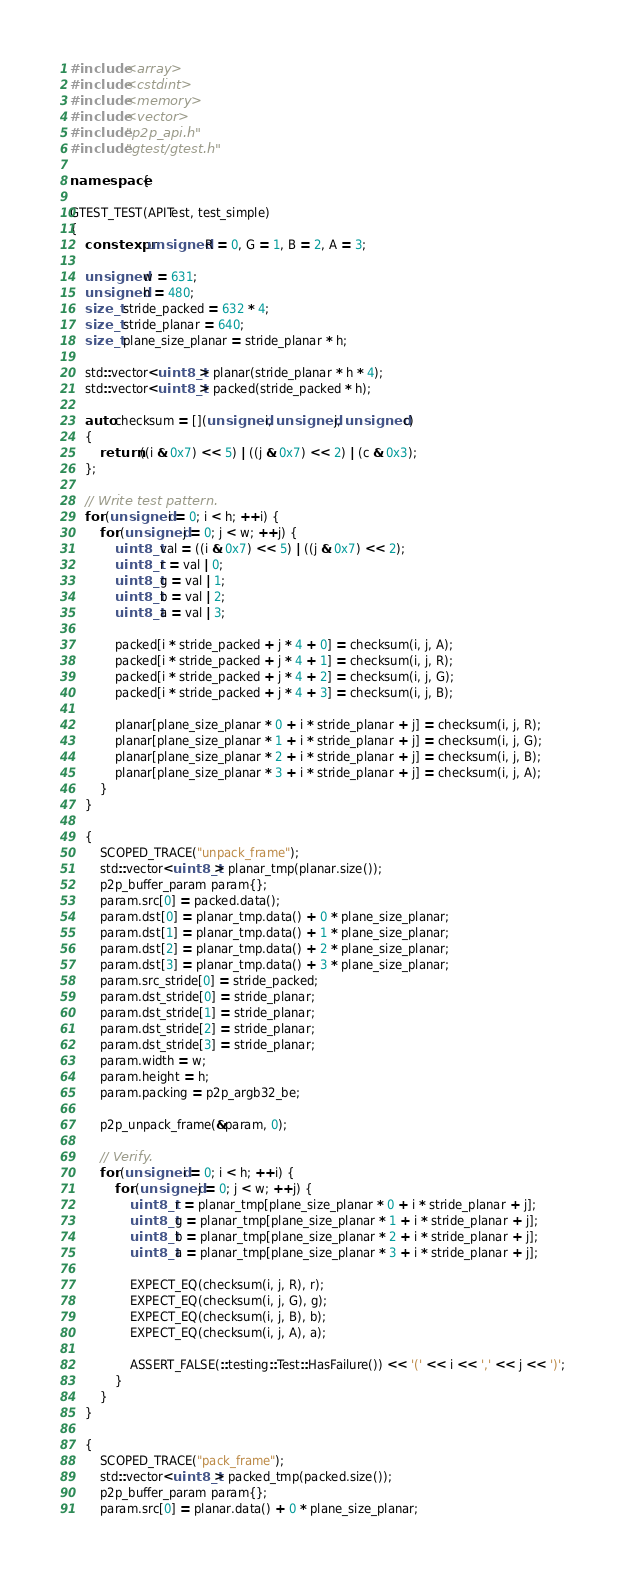Convert code to text. <code><loc_0><loc_0><loc_500><loc_500><_C++_>#include <array>
#include <cstdint>
#include <memory>
#include <vector>
#include "p2p_api.h"
#include "gtest/gtest.h"

namespace {

GTEST_TEST(APITest, test_simple)
{
	constexpr unsigned R = 0, G = 1, B = 2, A = 3;

	unsigned w = 631;
	unsigned h = 480;
	size_t stride_packed = 632 * 4;
	size_t stride_planar = 640;
	size_t plane_size_planar = stride_planar * h;

	std::vector<uint8_t> planar(stride_planar * h * 4);
	std::vector<uint8_t> packed(stride_packed * h);

	auto checksum = [](unsigned i, unsigned j, unsigned c)
	{
		return ((i & 0x7) << 5) | ((j & 0x7) << 2) | (c & 0x3);
	};

	// Write test pattern.
	for (unsigned i = 0; i < h; ++i) {
		for (unsigned j = 0; j < w; ++j) {
			uint8_t val = ((i & 0x7) << 5) | ((j & 0x7) << 2);
			uint8_t r = val | 0;
			uint8_t g = val | 1;
			uint8_t b = val | 2;
			uint8_t a = val | 3;

			packed[i * stride_packed + j * 4 + 0] = checksum(i, j, A);
			packed[i * stride_packed + j * 4 + 1] = checksum(i, j, R);
			packed[i * stride_packed + j * 4 + 2] = checksum(i, j, G);
			packed[i * stride_packed + j * 4 + 3] = checksum(i, j, B);

			planar[plane_size_planar * 0 + i * stride_planar + j] = checksum(i, j, R);
			planar[plane_size_planar * 1 + i * stride_planar + j] = checksum(i, j, G);
			planar[plane_size_planar * 2 + i * stride_planar + j] = checksum(i, j, B);
			planar[plane_size_planar * 3 + i * stride_planar + j] = checksum(i, j, A);
		}
	}

	{
		SCOPED_TRACE("unpack_frame");
		std::vector<uint8_t> planar_tmp(planar.size());
		p2p_buffer_param param{};
		param.src[0] = packed.data();
		param.dst[0] = planar_tmp.data() + 0 * plane_size_planar;
		param.dst[1] = planar_tmp.data() + 1 * plane_size_planar;
		param.dst[2] = planar_tmp.data() + 2 * plane_size_planar;
		param.dst[3] = planar_tmp.data() + 3 * plane_size_planar;
		param.src_stride[0] = stride_packed;
		param.dst_stride[0] = stride_planar;
		param.dst_stride[1] = stride_planar;
		param.dst_stride[2] = stride_planar;
		param.dst_stride[3] = stride_planar;
		param.width = w;
		param.height = h;
		param.packing = p2p_argb32_be;

		p2p_unpack_frame(&param, 0);

		// Verify.
		for (unsigned i = 0; i < h; ++i) {
			for (unsigned j = 0; j < w; ++j) {
				uint8_t r = planar_tmp[plane_size_planar * 0 + i * stride_planar + j];
				uint8_t g = planar_tmp[plane_size_planar * 1 + i * stride_planar + j];
				uint8_t b = planar_tmp[plane_size_planar * 2 + i * stride_planar + j];
				uint8_t a = planar_tmp[plane_size_planar * 3 + i * stride_planar + j];

				EXPECT_EQ(checksum(i, j, R), r);
				EXPECT_EQ(checksum(i, j, G), g);
				EXPECT_EQ(checksum(i, j, B), b);
				EXPECT_EQ(checksum(i, j, A), a);

				ASSERT_FALSE(::testing::Test::HasFailure()) << '(' << i << ',' << j << ')';
			}
		}
	}

	{
		SCOPED_TRACE("pack_frame");
		std::vector<uint8_t> packed_tmp(packed.size());
		p2p_buffer_param param{};
		param.src[0] = planar.data() + 0 * plane_size_planar;</code> 